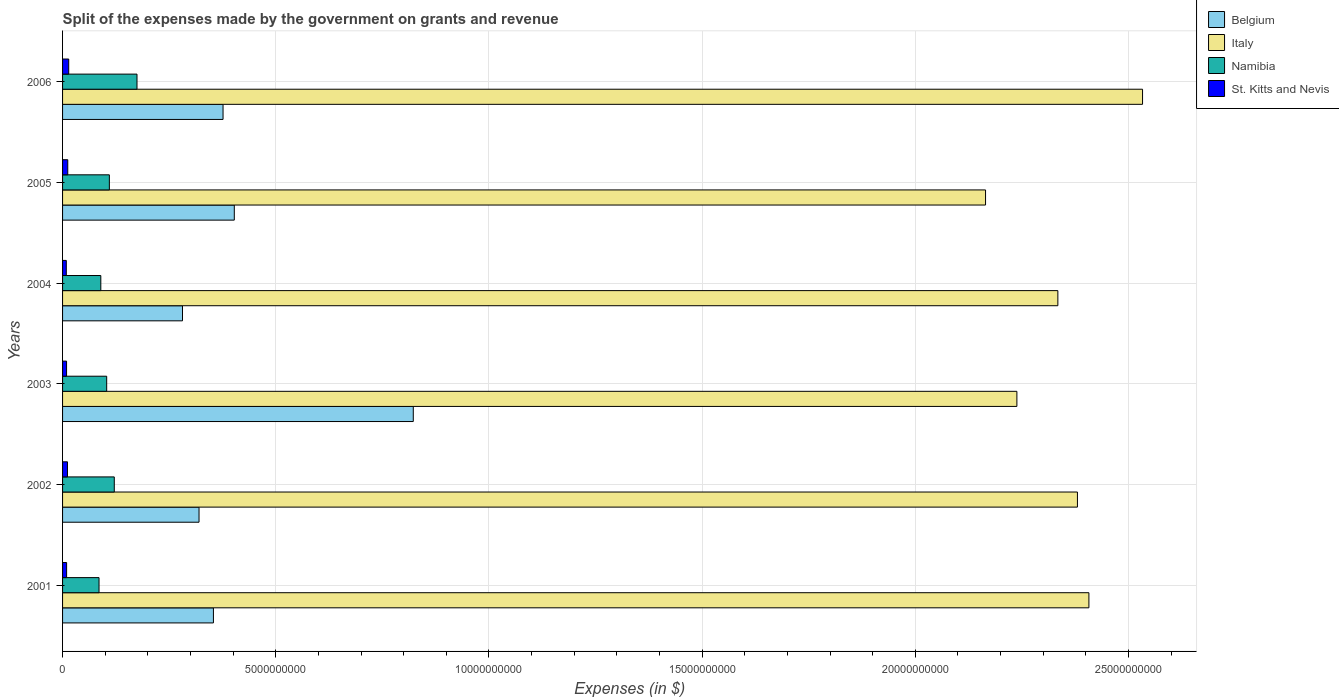How many groups of bars are there?
Provide a succinct answer. 6. In how many cases, is the number of bars for a given year not equal to the number of legend labels?
Your answer should be very brief. 0. What is the expenses made by the government on grants and revenue in St. Kitts and Nevis in 2001?
Provide a succinct answer. 9.49e+07. Across all years, what is the maximum expenses made by the government on grants and revenue in Belgium?
Your answer should be compact. 8.23e+09. Across all years, what is the minimum expenses made by the government on grants and revenue in Namibia?
Ensure brevity in your answer.  8.55e+08. In which year was the expenses made by the government on grants and revenue in Italy minimum?
Provide a short and direct response. 2005. What is the total expenses made by the government on grants and revenue in Italy in the graph?
Give a very brief answer. 1.41e+11. What is the difference between the expenses made by the government on grants and revenue in Belgium in 2003 and that in 2004?
Keep it short and to the point. 5.41e+09. What is the difference between the expenses made by the government on grants and revenue in St. Kitts and Nevis in 2004 and the expenses made by the government on grants and revenue in Belgium in 2002?
Provide a succinct answer. -3.11e+09. What is the average expenses made by the government on grants and revenue in Italy per year?
Your answer should be very brief. 2.34e+1. In the year 2003, what is the difference between the expenses made by the government on grants and revenue in Belgium and expenses made by the government on grants and revenue in Namibia?
Offer a terse response. 7.19e+09. In how many years, is the expenses made by the government on grants and revenue in St. Kitts and Nevis greater than 13000000000 $?
Your answer should be compact. 0. What is the ratio of the expenses made by the government on grants and revenue in Belgium in 2002 to that in 2003?
Provide a succinct answer. 0.39. Is the difference between the expenses made by the government on grants and revenue in Belgium in 2004 and 2006 greater than the difference between the expenses made by the government on grants and revenue in Namibia in 2004 and 2006?
Your answer should be compact. No. What is the difference between the highest and the second highest expenses made by the government on grants and revenue in Italy?
Provide a succinct answer. 1.26e+09. What is the difference between the highest and the lowest expenses made by the government on grants and revenue in St. Kitts and Nevis?
Provide a succinct answer. 5.68e+07. In how many years, is the expenses made by the government on grants and revenue in Italy greater than the average expenses made by the government on grants and revenue in Italy taken over all years?
Keep it short and to the point. 3. Is the sum of the expenses made by the government on grants and revenue in Namibia in 2001 and 2003 greater than the maximum expenses made by the government on grants and revenue in Belgium across all years?
Your answer should be compact. No. Is it the case that in every year, the sum of the expenses made by the government on grants and revenue in St. Kitts and Nevis and expenses made by the government on grants and revenue in Belgium is greater than the sum of expenses made by the government on grants and revenue in Namibia and expenses made by the government on grants and revenue in Italy?
Make the answer very short. Yes. What does the 2nd bar from the top in 2001 represents?
Offer a terse response. Namibia. What does the 4th bar from the bottom in 2006 represents?
Provide a short and direct response. St. Kitts and Nevis. How many years are there in the graph?
Provide a succinct answer. 6. What is the difference between two consecutive major ticks on the X-axis?
Give a very brief answer. 5.00e+09. Does the graph contain any zero values?
Keep it short and to the point. No. How many legend labels are there?
Keep it short and to the point. 4. How are the legend labels stacked?
Ensure brevity in your answer.  Vertical. What is the title of the graph?
Ensure brevity in your answer.  Split of the expenses made by the government on grants and revenue. What is the label or title of the X-axis?
Offer a terse response. Expenses (in $). What is the Expenses (in $) in Belgium in 2001?
Your answer should be compact. 3.54e+09. What is the Expenses (in $) in Italy in 2001?
Your response must be concise. 2.41e+1. What is the Expenses (in $) in Namibia in 2001?
Provide a succinct answer. 8.55e+08. What is the Expenses (in $) in St. Kitts and Nevis in 2001?
Provide a succinct answer. 9.49e+07. What is the Expenses (in $) in Belgium in 2002?
Keep it short and to the point. 3.20e+09. What is the Expenses (in $) of Italy in 2002?
Your answer should be very brief. 2.38e+1. What is the Expenses (in $) in Namibia in 2002?
Your answer should be very brief. 1.21e+09. What is the Expenses (in $) in St. Kitts and Nevis in 2002?
Your response must be concise. 1.15e+08. What is the Expenses (in $) in Belgium in 2003?
Ensure brevity in your answer.  8.23e+09. What is the Expenses (in $) of Italy in 2003?
Keep it short and to the point. 2.24e+1. What is the Expenses (in $) in Namibia in 2003?
Ensure brevity in your answer.  1.03e+09. What is the Expenses (in $) in St. Kitts and Nevis in 2003?
Make the answer very short. 9.36e+07. What is the Expenses (in $) in Belgium in 2004?
Give a very brief answer. 2.81e+09. What is the Expenses (in $) in Italy in 2004?
Ensure brevity in your answer.  2.33e+1. What is the Expenses (in $) of Namibia in 2004?
Offer a terse response. 8.97e+08. What is the Expenses (in $) in St. Kitts and Nevis in 2004?
Ensure brevity in your answer.  8.76e+07. What is the Expenses (in $) in Belgium in 2005?
Your answer should be compact. 4.03e+09. What is the Expenses (in $) of Italy in 2005?
Your answer should be very brief. 2.16e+1. What is the Expenses (in $) of Namibia in 2005?
Make the answer very short. 1.10e+09. What is the Expenses (in $) in St. Kitts and Nevis in 2005?
Offer a very short reply. 1.22e+08. What is the Expenses (in $) of Belgium in 2006?
Your answer should be very brief. 3.76e+09. What is the Expenses (in $) of Italy in 2006?
Make the answer very short. 2.53e+1. What is the Expenses (in $) in Namibia in 2006?
Provide a succinct answer. 1.75e+09. What is the Expenses (in $) in St. Kitts and Nevis in 2006?
Your answer should be compact. 1.44e+08. Across all years, what is the maximum Expenses (in $) in Belgium?
Provide a short and direct response. 8.23e+09. Across all years, what is the maximum Expenses (in $) of Italy?
Make the answer very short. 2.53e+1. Across all years, what is the maximum Expenses (in $) of Namibia?
Your answer should be very brief. 1.75e+09. Across all years, what is the maximum Expenses (in $) in St. Kitts and Nevis?
Offer a terse response. 1.44e+08. Across all years, what is the minimum Expenses (in $) of Belgium?
Your answer should be compact. 2.81e+09. Across all years, what is the minimum Expenses (in $) of Italy?
Give a very brief answer. 2.16e+1. Across all years, what is the minimum Expenses (in $) in Namibia?
Your answer should be compact. 8.55e+08. Across all years, what is the minimum Expenses (in $) of St. Kitts and Nevis?
Offer a very short reply. 8.76e+07. What is the total Expenses (in $) of Belgium in the graph?
Ensure brevity in your answer.  2.56e+1. What is the total Expenses (in $) in Italy in the graph?
Provide a succinct answer. 1.41e+11. What is the total Expenses (in $) in Namibia in the graph?
Your answer should be very brief. 6.84e+09. What is the total Expenses (in $) in St. Kitts and Nevis in the graph?
Offer a terse response. 6.58e+08. What is the difference between the Expenses (in $) in Belgium in 2001 and that in 2002?
Your response must be concise. 3.37e+08. What is the difference between the Expenses (in $) in Italy in 2001 and that in 2002?
Provide a short and direct response. 2.69e+08. What is the difference between the Expenses (in $) in Namibia in 2001 and that in 2002?
Your answer should be compact. -3.58e+08. What is the difference between the Expenses (in $) in St. Kitts and Nevis in 2001 and that in 2002?
Provide a short and direct response. -2.04e+07. What is the difference between the Expenses (in $) of Belgium in 2001 and that in 2003?
Provide a short and direct response. -4.69e+09. What is the difference between the Expenses (in $) of Italy in 2001 and that in 2003?
Your response must be concise. 1.69e+09. What is the difference between the Expenses (in $) of Namibia in 2001 and that in 2003?
Give a very brief answer. -1.80e+08. What is the difference between the Expenses (in $) of St. Kitts and Nevis in 2001 and that in 2003?
Provide a short and direct response. 1.30e+06. What is the difference between the Expenses (in $) of Belgium in 2001 and that in 2004?
Provide a succinct answer. 7.25e+08. What is the difference between the Expenses (in $) in Italy in 2001 and that in 2004?
Your answer should be compact. 7.28e+08. What is the difference between the Expenses (in $) in Namibia in 2001 and that in 2004?
Your answer should be compact. -4.18e+07. What is the difference between the Expenses (in $) in St. Kitts and Nevis in 2001 and that in 2004?
Ensure brevity in your answer.  7.30e+06. What is the difference between the Expenses (in $) of Belgium in 2001 and that in 2005?
Make the answer very short. -4.90e+08. What is the difference between the Expenses (in $) in Italy in 2001 and that in 2005?
Keep it short and to the point. 2.42e+09. What is the difference between the Expenses (in $) of Namibia in 2001 and that in 2005?
Your answer should be very brief. -2.42e+08. What is the difference between the Expenses (in $) of St. Kitts and Nevis in 2001 and that in 2005?
Offer a very short reply. -2.69e+07. What is the difference between the Expenses (in $) of Belgium in 2001 and that in 2006?
Keep it short and to the point. -2.26e+08. What is the difference between the Expenses (in $) of Italy in 2001 and that in 2006?
Your response must be concise. -1.26e+09. What is the difference between the Expenses (in $) in Namibia in 2001 and that in 2006?
Ensure brevity in your answer.  -8.90e+08. What is the difference between the Expenses (in $) of St. Kitts and Nevis in 2001 and that in 2006?
Provide a short and direct response. -4.95e+07. What is the difference between the Expenses (in $) of Belgium in 2002 and that in 2003?
Keep it short and to the point. -5.02e+09. What is the difference between the Expenses (in $) of Italy in 2002 and that in 2003?
Offer a terse response. 1.42e+09. What is the difference between the Expenses (in $) in Namibia in 2002 and that in 2003?
Make the answer very short. 1.78e+08. What is the difference between the Expenses (in $) in St. Kitts and Nevis in 2002 and that in 2003?
Offer a terse response. 2.17e+07. What is the difference between the Expenses (in $) in Belgium in 2002 and that in 2004?
Ensure brevity in your answer.  3.88e+08. What is the difference between the Expenses (in $) in Italy in 2002 and that in 2004?
Your answer should be very brief. 4.59e+08. What is the difference between the Expenses (in $) in Namibia in 2002 and that in 2004?
Your answer should be very brief. 3.16e+08. What is the difference between the Expenses (in $) in St. Kitts and Nevis in 2002 and that in 2004?
Your answer should be compact. 2.77e+07. What is the difference between the Expenses (in $) in Belgium in 2002 and that in 2005?
Ensure brevity in your answer.  -8.27e+08. What is the difference between the Expenses (in $) of Italy in 2002 and that in 2005?
Your response must be concise. 2.16e+09. What is the difference between the Expenses (in $) in Namibia in 2002 and that in 2005?
Provide a short and direct response. 1.15e+08. What is the difference between the Expenses (in $) of St. Kitts and Nevis in 2002 and that in 2005?
Provide a succinct answer. -6.50e+06. What is the difference between the Expenses (in $) in Belgium in 2002 and that in 2006?
Your answer should be compact. -5.63e+08. What is the difference between the Expenses (in $) of Italy in 2002 and that in 2006?
Ensure brevity in your answer.  -1.53e+09. What is the difference between the Expenses (in $) of Namibia in 2002 and that in 2006?
Keep it short and to the point. -5.33e+08. What is the difference between the Expenses (in $) of St. Kitts and Nevis in 2002 and that in 2006?
Provide a short and direct response. -2.91e+07. What is the difference between the Expenses (in $) of Belgium in 2003 and that in 2004?
Ensure brevity in your answer.  5.41e+09. What is the difference between the Expenses (in $) of Italy in 2003 and that in 2004?
Offer a very short reply. -9.61e+08. What is the difference between the Expenses (in $) in Namibia in 2003 and that in 2004?
Offer a very short reply. 1.38e+08. What is the difference between the Expenses (in $) of Belgium in 2003 and that in 2005?
Your response must be concise. 4.20e+09. What is the difference between the Expenses (in $) in Italy in 2003 and that in 2005?
Offer a very short reply. 7.35e+08. What is the difference between the Expenses (in $) of Namibia in 2003 and that in 2005?
Provide a succinct answer. -6.28e+07. What is the difference between the Expenses (in $) of St. Kitts and Nevis in 2003 and that in 2005?
Your answer should be very brief. -2.82e+07. What is the difference between the Expenses (in $) of Belgium in 2003 and that in 2006?
Your response must be concise. 4.46e+09. What is the difference between the Expenses (in $) in Italy in 2003 and that in 2006?
Your answer should be very brief. -2.95e+09. What is the difference between the Expenses (in $) in Namibia in 2003 and that in 2006?
Provide a succinct answer. -7.11e+08. What is the difference between the Expenses (in $) in St. Kitts and Nevis in 2003 and that in 2006?
Keep it short and to the point. -5.08e+07. What is the difference between the Expenses (in $) in Belgium in 2004 and that in 2005?
Your answer should be compact. -1.21e+09. What is the difference between the Expenses (in $) in Italy in 2004 and that in 2005?
Provide a succinct answer. 1.70e+09. What is the difference between the Expenses (in $) in Namibia in 2004 and that in 2005?
Provide a short and direct response. -2.00e+08. What is the difference between the Expenses (in $) of St. Kitts and Nevis in 2004 and that in 2005?
Offer a terse response. -3.42e+07. What is the difference between the Expenses (in $) of Belgium in 2004 and that in 2006?
Offer a very short reply. -9.51e+08. What is the difference between the Expenses (in $) of Italy in 2004 and that in 2006?
Give a very brief answer. -1.99e+09. What is the difference between the Expenses (in $) of Namibia in 2004 and that in 2006?
Provide a short and direct response. -8.49e+08. What is the difference between the Expenses (in $) of St. Kitts and Nevis in 2004 and that in 2006?
Your answer should be compact. -5.68e+07. What is the difference between the Expenses (in $) in Belgium in 2005 and that in 2006?
Make the answer very short. 2.64e+08. What is the difference between the Expenses (in $) of Italy in 2005 and that in 2006?
Ensure brevity in your answer.  -3.68e+09. What is the difference between the Expenses (in $) in Namibia in 2005 and that in 2006?
Make the answer very short. -6.48e+08. What is the difference between the Expenses (in $) in St. Kitts and Nevis in 2005 and that in 2006?
Your answer should be compact. -2.26e+07. What is the difference between the Expenses (in $) of Belgium in 2001 and the Expenses (in $) of Italy in 2002?
Ensure brevity in your answer.  -2.03e+1. What is the difference between the Expenses (in $) in Belgium in 2001 and the Expenses (in $) in Namibia in 2002?
Give a very brief answer. 2.32e+09. What is the difference between the Expenses (in $) in Belgium in 2001 and the Expenses (in $) in St. Kitts and Nevis in 2002?
Keep it short and to the point. 3.42e+09. What is the difference between the Expenses (in $) in Italy in 2001 and the Expenses (in $) in Namibia in 2002?
Offer a very short reply. 2.29e+1. What is the difference between the Expenses (in $) of Italy in 2001 and the Expenses (in $) of St. Kitts and Nevis in 2002?
Offer a terse response. 2.40e+1. What is the difference between the Expenses (in $) in Namibia in 2001 and the Expenses (in $) in St. Kitts and Nevis in 2002?
Provide a succinct answer. 7.40e+08. What is the difference between the Expenses (in $) of Belgium in 2001 and the Expenses (in $) of Italy in 2003?
Give a very brief answer. -1.88e+1. What is the difference between the Expenses (in $) in Belgium in 2001 and the Expenses (in $) in Namibia in 2003?
Give a very brief answer. 2.50e+09. What is the difference between the Expenses (in $) of Belgium in 2001 and the Expenses (in $) of St. Kitts and Nevis in 2003?
Ensure brevity in your answer.  3.44e+09. What is the difference between the Expenses (in $) of Italy in 2001 and the Expenses (in $) of Namibia in 2003?
Provide a short and direct response. 2.30e+1. What is the difference between the Expenses (in $) of Italy in 2001 and the Expenses (in $) of St. Kitts and Nevis in 2003?
Provide a succinct answer. 2.40e+1. What is the difference between the Expenses (in $) in Namibia in 2001 and the Expenses (in $) in St. Kitts and Nevis in 2003?
Give a very brief answer. 7.62e+08. What is the difference between the Expenses (in $) of Belgium in 2001 and the Expenses (in $) of Italy in 2004?
Ensure brevity in your answer.  -1.98e+1. What is the difference between the Expenses (in $) of Belgium in 2001 and the Expenses (in $) of Namibia in 2004?
Your answer should be compact. 2.64e+09. What is the difference between the Expenses (in $) of Belgium in 2001 and the Expenses (in $) of St. Kitts and Nevis in 2004?
Offer a very short reply. 3.45e+09. What is the difference between the Expenses (in $) of Italy in 2001 and the Expenses (in $) of Namibia in 2004?
Give a very brief answer. 2.32e+1. What is the difference between the Expenses (in $) of Italy in 2001 and the Expenses (in $) of St. Kitts and Nevis in 2004?
Your answer should be very brief. 2.40e+1. What is the difference between the Expenses (in $) in Namibia in 2001 and the Expenses (in $) in St. Kitts and Nevis in 2004?
Offer a terse response. 7.68e+08. What is the difference between the Expenses (in $) of Belgium in 2001 and the Expenses (in $) of Italy in 2005?
Your response must be concise. -1.81e+1. What is the difference between the Expenses (in $) of Belgium in 2001 and the Expenses (in $) of Namibia in 2005?
Provide a short and direct response. 2.44e+09. What is the difference between the Expenses (in $) in Belgium in 2001 and the Expenses (in $) in St. Kitts and Nevis in 2005?
Your answer should be compact. 3.42e+09. What is the difference between the Expenses (in $) in Italy in 2001 and the Expenses (in $) in Namibia in 2005?
Give a very brief answer. 2.30e+1. What is the difference between the Expenses (in $) in Italy in 2001 and the Expenses (in $) in St. Kitts and Nevis in 2005?
Give a very brief answer. 2.39e+1. What is the difference between the Expenses (in $) in Namibia in 2001 and the Expenses (in $) in St. Kitts and Nevis in 2005?
Your response must be concise. 7.34e+08. What is the difference between the Expenses (in $) of Belgium in 2001 and the Expenses (in $) of Italy in 2006?
Make the answer very short. -2.18e+1. What is the difference between the Expenses (in $) in Belgium in 2001 and the Expenses (in $) in Namibia in 2006?
Provide a succinct answer. 1.79e+09. What is the difference between the Expenses (in $) of Belgium in 2001 and the Expenses (in $) of St. Kitts and Nevis in 2006?
Your response must be concise. 3.39e+09. What is the difference between the Expenses (in $) of Italy in 2001 and the Expenses (in $) of Namibia in 2006?
Offer a very short reply. 2.23e+1. What is the difference between the Expenses (in $) of Italy in 2001 and the Expenses (in $) of St. Kitts and Nevis in 2006?
Give a very brief answer. 2.39e+1. What is the difference between the Expenses (in $) of Namibia in 2001 and the Expenses (in $) of St. Kitts and Nevis in 2006?
Give a very brief answer. 7.11e+08. What is the difference between the Expenses (in $) of Belgium in 2002 and the Expenses (in $) of Italy in 2003?
Your answer should be very brief. -1.92e+1. What is the difference between the Expenses (in $) of Belgium in 2002 and the Expenses (in $) of Namibia in 2003?
Offer a very short reply. 2.17e+09. What is the difference between the Expenses (in $) of Belgium in 2002 and the Expenses (in $) of St. Kitts and Nevis in 2003?
Your response must be concise. 3.11e+09. What is the difference between the Expenses (in $) of Italy in 2002 and the Expenses (in $) of Namibia in 2003?
Provide a short and direct response. 2.28e+1. What is the difference between the Expenses (in $) of Italy in 2002 and the Expenses (in $) of St. Kitts and Nevis in 2003?
Offer a terse response. 2.37e+1. What is the difference between the Expenses (in $) of Namibia in 2002 and the Expenses (in $) of St. Kitts and Nevis in 2003?
Provide a succinct answer. 1.12e+09. What is the difference between the Expenses (in $) in Belgium in 2002 and the Expenses (in $) in Italy in 2004?
Your answer should be compact. -2.01e+1. What is the difference between the Expenses (in $) of Belgium in 2002 and the Expenses (in $) of Namibia in 2004?
Your answer should be very brief. 2.30e+09. What is the difference between the Expenses (in $) of Belgium in 2002 and the Expenses (in $) of St. Kitts and Nevis in 2004?
Provide a succinct answer. 3.11e+09. What is the difference between the Expenses (in $) in Italy in 2002 and the Expenses (in $) in Namibia in 2004?
Offer a terse response. 2.29e+1. What is the difference between the Expenses (in $) in Italy in 2002 and the Expenses (in $) in St. Kitts and Nevis in 2004?
Your answer should be very brief. 2.37e+1. What is the difference between the Expenses (in $) of Namibia in 2002 and the Expenses (in $) of St. Kitts and Nevis in 2004?
Offer a very short reply. 1.13e+09. What is the difference between the Expenses (in $) in Belgium in 2002 and the Expenses (in $) in Italy in 2005?
Provide a short and direct response. -1.84e+1. What is the difference between the Expenses (in $) in Belgium in 2002 and the Expenses (in $) in Namibia in 2005?
Offer a terse response. 2.10e+09. What is the difference between the Expenses (in $) in Belgium in 2002 and the Expenses (in $) in St. Kitts and Nevis in 2005?
Offer a very short reply. 3.08e+09. What is the difference between the Expenses (in $) of Italy in 2002 and the Expenses (in $) of Namibia in 2005?
Make the answer very short. 2.27e+1. What is the difference between the Expenses (in $) in Italy in 2002 and the Expenses (in $) in St. Kitts and Nevis in 2005?
Give a very brief answer. 2.37e+1. What is the difference between the Expenses (in $) of Namibia in 2002 and the Expenses (in $) of St. Kitts and Nevis in 2005?
Give a very brief answer. 1.09e+09. What is the difference between the Expenses (in $) in Belgium in 2002 and the Expenses (in $) in Italy in 2006?
Give a very brief answer. -2.21e+1. What is the difference between the Expenses (in $) of Belgium in 2002 and the Expenses (in $) of Namibia in 2006?
Keep it short and to the point. 1.45e+09. What is the difference between the Expenses (in $) of Belgium in 2002 and the Expenses (in $) of St. Kitts and Nevis in 2006?
Offer a very short reply. 3.06e+09. What is the difference between the Expenses (in $) of Italy in 2002 and the Expenses (in $) of Namibia in 2006?
Provide a succinct answer. 2.21e+1. What is the difference between the Expenses (in $) in Italy in 2002 and the Expenses (in $) in St. Kitts and Nevis in 2006?
Give a very brief answer. 2.37e+1. What is the difference between the Expenses (in $) of Namibia in 2002 and the Expenses (in $) of St. Kitts and Nevis in 2006?
Offer a very short reply. 1.07e+09. What is the difference between the Expenses (in $) in Belgium in 2003 and the Expenses (in $) in Italy in 2004?
Provide a succinct answer. -1.51e+1. What is the difference between the Expenses (in $) in Belgium in 2003 and the Expenses (in $) in Namibia in 2004?
Your response must be concise. 7.33e+09. What is the difference between the Expenses (in $) in Belgium in 2003 and the Expenses (in $) in St. Kitts and Nevis in 2004?
Your response must be concise. 8.14e+09. What is the difference between the Expenses (in $) in Italy in 2003 and the Expenses (in $) in Namibia in 2004?
Give a very brief answer. 2.15e+1. What is the difference between the Expenses (in $) of Italy in 2003 and the Expenses (in $) of St. Kitts and Nevis in 2004?
Your answer should be very brief. 2.23e+1. What is the difference between the Expenses (in $) of Namibia in 2003 and the Expenses (in $) of St. Kitts and Nevis in 2004?
Provide a short and direct response. 9.47e+08. What is the difference between the Expenses (in $) in Belgium in 2003 and the Expenses (in $) in Italy in 2005?
Your response must be concise. -1.34e+1. What is the difference between the Expenses (in $) in Belgium in 2003 and the Expenses (in $) in Namibia in 2005?
Your response must be concise. 7.13e+09. What is the difference between the Expenses (in $) in Belgium in 2003 and the Expenses (in $) in St. Kitts and Nevis in 2005?
Give a very brief answer. 8.10e+09. What is the difference between the Expenses (in $) of Italy in 2003 and the Expenses (in $) of Namibia in 2005?
Keep it short and to the point. 2.13e+1. What is the difference between the Expenses (in $) in Italy in 2003 and the Expenses (in $) in St. Kitts and Nevis in 2005?
Your response must be concise. 2.23e+1. What is the difference between the Expenses (in $) in Namibia in 2003 and the Expenses (in $) in St. Kitts and Nevis in 2005?
Ensure brevity in your answer.  9.13e+08. What is the difference between the Expenses (in $) of Belgium in 2003 and the Expenses (in $) of Italy in 2006?
Provide a short and direct response. -1.71e+1. What is the difference between the Expenses (in $) in Belgium in 2003 and the Expenses (in $) in Namibia in 2006?
Make the answer very short. 6.48e+09. What is the difference between the Expenses (in $) in Belgium in 2003 and the Expenses (in $) in St. Kitts and Nevis in 2006?
Give a very brief answer. 8.08e+09. What is the difference between the Expenses (in $) in Italy in 2003 and the Expenses (in $) in Namibia in 2006?
Your answer should be very brief. 2.06e+1. What is the difference between the Expenses (in $) of Italy in 2003 and the Expenses (in $) of St. Kitts and Nevis in 2006?
Make the answer very short. 2.22e+1. What is the difference between the Expenses (in $) of Namibia in 2003 and the Expenses (in $) of St. Kitts and Nevis in 2006?
Give a very brief answer. 8.90e+08. What is the difference between the Expenses (in $) in Belgium in 2004 and the Expenses (in $) in Italy in 2005?
Your response must be concise. -1.88e+1. What is the difference between the Expenses (in $) in Belgium in 2004 and the Expenses (in $) in Namibia in 2005?
Offer a very short reply. 1.72e+09. What is the difference between the Expenses (in $) of Belgium in 2004 and the Expenses (in $) of St. Kitts and Nevis in 2005?
Keep it short and to the point. 2.69e+09. What is the difference between the Expenses (in $) of Italy in 2004 and the Expenses (in $) of Namibia in 2005?
Give a very brief answer. 2.22e+1. What is the difference between the Expenses (in $) in Italy in 2004 and the Expenses (in $) in St. Kitts and Nevis in 2005?
Offer a terse response. 2.32e+1. What is the difference between the Expenses (in $) in Namibia in 2004 and the Expenses (in $) in St. Kitts and Nevis in 2005?
Provide a succinct answer. 7.75e+08. What is the difference between the Expenses (in $) in Belgium in 2004 and the Expenses (in $) in Italy in 2006?
Keep it short and to the point. -2.25e+1. What is the difference between the Expenses (in $) of Belgium in 2004 and the Expenses (in $) of Namibia in 2006?
Provide a succinct answer. 1.07e+09. What is the difference between the Expenses (in $) of Belgium in 2004 and the Expenses (in $) of St. Kitts and Nevis in 2006?
Offer a terse response. 2.67e+09. What is the difference between the Expenses (in $) in Italy in 2004 and the Expenses (in $) in Namibia in 2006?
Provide a succinct answer. 2.16e+1. What is the difference between the Expenses (in $) of Italy in 2004 and the Expenses (in $) of St. Kitts and Nevis in 2006?
Keep it short and to the point. 2.32e+1. What is the difference between the Expenses (in $) in Namibia in 2004 and the Expenses (in $) in St. Kitts and Nevis in 2006?
Your answer should be compact. 7.53e+08. What is the difference between the Expenses (in $) of Belgium in 2005 and the Expenses (in $) of Italy in 2006?
Provide a short and direct response. -2.13e+1. What is the difference between the Expenses (in $) in Belgium in 2005 and the Expenses (in $) in Namibia in 2006?
Offer a terse response. 2.28e+09. What is the difference between the Expenses (in $) in Belgium in 2005 and the Expenses (in $) in St. Kitts and Nevis in 2006?
Your answer should be very brief. 3.88e+09. What is the difference between the Expenses (in $) of Italy in 2005 and the Expenses (in $) of Namibia in 2006?
Ensure brevity in your answer.  1.99e+1. What is the difference between the Expenses (in $) of Italy in 2005 and the Expenses (in $) of St. Kitts and Nevis in 2006?
Make the answer very short. 2.15e+1. What is the difference between the Expenses (in $) of Namibia in 2005 and the Expenses (in $) of St. Kitts and Nevis in 2006?
Give a very brief answer. 9.53e+08. What is the average Expenses (in $) of Belgium per year?
Your answer should be compact. 4.26e+09. What is the average Expenses (in $) of Italy per year?
Keep it short and to the point. 2.34e+1. What is the average Expenses (in $) in Namibia per year?
Your response must be concise. 1.14e+09. What is the average Expenses (in $) in St. Kitts and Nevis per year?
Your answer should be very brief. 1.10e+08. In the year 2001, what is the difference between the Expenses (in $) of Belgium and Expenses (in $) of Italy?
Offer a terse response. -2.05e+1. In the year 2001, what is the difference between the Expenses (in $) in Belgium and Expenses (in $) in Namibia?
Offer a very short reply. 2.68e+09. In the year 2001, what is the difference between the Expenses (in $) of Belgium and Expenses (in $) of St. Kitts and Nevis?
Ensure brevity in your answer.  3.44e+09. In the year 2001, what is the difference between the Expenses (in $) in Italy and Expenses (in $) in Namibia?
Provide a succinct answer. 2.32e+1. In the year 2001, what is the difference between the Expenses (in $) in Italy and Expenses (in $) in St. Kitts and Nevis?
Your answer should be compact. 2.40e+1. In the year 2001, what is the difference between the Expenses (in $) of Namibia and Expenses (in $) of St. Kitts and Nevis?
Provide a short and direct response. 7.60e+08. In the year 2002, what is the difference between the Expenses (in $) in Belgium and Expenses (in $) in Italy?
Your response must be concise. -2.06e+1. In the year 2002, what is the difference between the Expenses (in $) of Belgium and Expenses (in $) of Namibia?
Your answer should be very brief. 1.99e+09. In the year 2002, what is the difference between the Expenses (in $) in Belgium and Expenses (in $) in St. Kitts and Nevis?
Keep it short and to the point. 3.09e+09. In the year 2002, what is the difference between the Expenses (in $) in Italy and Expenses (in $) in Namibia?
Keep it short and to the point. 2.26e+1. In the year 2002, what is the difference between the Expenses (in $) in Italy and Expenses (in $) in St. Kitts and Nevis?
Your response must be concise. 2.37e+1. In the year 2002, what is the difference between the Expenses (in $) in Namibia and Expenses (in $) in St. Kitts and Nevis?
Ensure brevity in your answer.  1.10e+09. In the year 2003, what is the difference between the Expenses (in $) in Belgium and Expenses (in $) in Italy?
Keep it short and to the point. -1.42e+1. In the year 2003, what is the difference between the Expenses (in $) of Belgium and Expenses (in $) of Namibia?
Make the answer very short. 7.19e+09. In the year 2003, what is the difference between the Expenses (in $) in Belgium and Expenses (in $) in St. Kitts and Nevis?
Your answer should be compact. 8.13e+09. In the year 2003, what is the difference between the Expenses (in $) in Italy and Expenses (in $) in Namibia?
Offer a terse response. 2.13e+1. In the year 2003, what is the difference between the Expenses (in $) in Italy and Expenses (in $) in St. Kitts and Nevis?
Provide a succinct answer. 2.23e+1. In the year 2003, what is the difference between the Expenses (in $) in Namibia and Expenses (in $) in St. Kitts and Nevis?
Keep it short and to the point. 9.41e+08. In the year 2004, what is the difference between the Expenses (in $) of Belgium and Expenses (in $) of Italy?
Your answer should be very brief. -2.05e+1. In the year 2004, what is the difference between the Expenses (in $) in Belgium and Expenses (in $) in Namibia?
Your answer should be compact. 1.92e+09. In the year 2004, what is the difference between the Expenses (in $) in Belgium and Expenses (in $) in St. Kitts and Nevis?
Make the answer very short. 2.73e+09. In the year 2004, what is the difference between the Expenses (in $) in Italy and Expenses (in $) in Namibia?
Provide a short and direct response. 2.24e+1. In the year 2004, what is the difference between the Expenses (in $) in Italy and Expenses (in $) in St. Kitts and Nevis?
Your response must be concise. 2.33e+1. In the year 2004, what is the difference between the Expenses (in $) in Namibia and Expenses (in $) in St. Kitts and Nevis?
Keep it short and to the point. 8.10e+08. In the year 2005, what is the difference between the Expenses (in $) in Belgium and Expenses (in $) in Italy?
Keep it short and to the point. -1.76e+1. In the year 2005, what is the difference between the Expenses (in $) in Belgium and Expenses (in $) in Namibia?
Give a very brief answer. 2.93e+09. In the year 2005, what is the difference between the Expenses (in $) in Belgium and Expenses (in $) in St. Kitts and Nevis?
Your answer should be very brief. 3.91e+09. In the year 2005, what is the difference between the Expenses (in $) of Italy and Expenses (in $) of Namibia?
Provide a short and direct response. 2.05e+1. In the year 2005, what is the difference between the Expenses (in $) of Italy and Expenses (in $) of St. Kitts and Nevis?
Ensure brevity in your answer.  2.15e+1. In the year 2005, what is the difference between the Expenses (in $) in Namibia and Expenses (in $) in St. Kitts and Nevis?
Your answer should be very brief. 9.76e+08. In the year 2006, what is the difference between the Expenses (in $) of Belgium and Expenses (in $) of Italy?
Offer a very short reply. -2.16e+1. In the year 2006, what is the difference between the Expenses (in $) in Belgium and Expenses (in $) in Namibia?
Provide a short and direct response. 2.02e+09. In the year 2006, what is the difference between the Expenses (in $) of Belgium and Expenses (in $) of St. Kitts and Nevis?
Your answer should be very brief. 3.62e+09. In the year 2006, what is the difference between the Expenses (in $) of Italy and Expenses (in $) of Namibia?
Make the answer very short. 2.36e+1. In the year 2006, what is the difference between the Expenses (in $) of Italy and Expenses (in $) of St. Kitts and Nevis?
Make the answer very short. 2.52e+1. In the year 2006, what is the difference between the Expenses (in $) of Namibia and Expenses (in $) of St. Kitts and Nevis?
Keep it short and to the point. 1.60e+09. What is the ratio of the Expenses (in $) in Belgium in 2001 to that in 2002?
Offer a terse response. 1.11. What is the ratio of the Expenses (in $) of Italy in 2001 to that in 2002?
Your answer should be compact. 1.01. What is the ratio of the Expenses (in $) in Namibia in 2001 to that in 2002?
Provide a succinct answer. 0.71. What is the ratio of the Expenses (in $) in St. Kitts and Nevis in 2001 to that in 2002?
Your answer should be very brief. 0.82. What is the ratio of the Expenses (in $) in Belgium in 2001 to that in 2003?
Offer a very short reply. 0.43. What is the ratio of the Expenses (in $) in Italy in 2001 to that in 2003?
Your answer should be compact. 1.08. What is the ratio of the Expenses (in $) in Namibia in 2001 to that in 2003?
Your answer should be very brief. 0.83. What is the ratio of the Expenses (in $) in St. Kitts and Nevis in 2001 to that in 2003?
Make the answer very short. 1.01. What is the ratio of the Expenses (in $) in Belgium in 2001 to that in 2004?
Offer a very short reply. 1.26. What is the ratio of the Expenses (in $) of Italy in 2001 to that in 2004?
Keep it short and to the point. 1.03. What is the ratio of the Expenses (in $) in Namibia in 2001 to that in 2004?
Give a very brief answer. 0.95. What is the ratio of the Expenses (in $) of Belgium in 2001 to that in 2005?
Provide a short and direct response. 0.88. What is the ratio of the Expenses (in $) in Italy in 2001 to that in 2005?
Give a very brief answer. 1.11. What is the ratio of the Expenses (in $) of Namibia in 2001 to that in 2005?
Ensure brevity in your answer.  0.78. What is the ratio of the Expenses (in $) of St. Kitts and Nevis in 2001 to that in 2005?
Give a very brief answer. 0.78. What is the ratio of the Expenses (in $) of Belgium in 2001 to that in 2006?
Offer a very short reply. 0.94. What is the ratio of the Expenses (in $) in Italy in 2001 to that in 2006?
Your response must be concise. 0.95. What is the ratio of the Expenses (in $) of Namibia in 2001 to that in 2006?
Provide a succinct answer. 0.49. What is the ratio of the Expenses (in $) of St. Kitts and Nevis in 2001 to that in 2006?
Provide a succinct answer. 0.66. What is the ratio of the Expenses (in $) in Belgium in 2002 to that in 2003?
Your answer should be very brief. 0.39. What is the ratio of the Expenses (in $) of Italy in 2002 to that in 2003?
Offer a terse response. 1.06. What is the ratio of the Expenses (in $) in Namibia in 2002 to that in 2003?
Make the answer very short. 1.17. What is the ratio of the Expenses (in $) in St. Kitts and Nevis in 2002 to that in 2003?
Keep it short and to the point. 1.23. What is the ratio of the Expenses (in $) of Belgium in 2002 to that in 2004?
Offer a very short reply. 1.14. What is the ratio of the Expenses (in $) of Italy in 2002 to that in 2004?
Provide a short and direct response. 1.02. What is the ratio of the Expenses (in $) in Namibia in 2002 to that in 2004?
Keep it short and to the point. 1.35. What is the ratio of the Expenses (in $) in St. Kitts and Nevis in 2002 to that in 2004?
Offer a terse response. 1.32. What is the ratio of the Expenses (in $) in Belgium in 2002 to that in 2005?
Offer a very short reply. 0.79. What is the ratio of the Expenses (in $) in Italy in 2002 to that in 2005?
Give a very brief answer. 1.1. What is the ratio of the Expenses (in $) in Namibia in 2002 to that in 2005?
Provide a short and direct response. 1.11. What is the ratio of the Expenses (in $) of St. Kitts and Nevis in 2002 to that in 2005?
Ensure brevity in your answer.  0.95. What is the ratio of the Expenses (in $) of Belgium in 2002 to that in 2006?
Keep it short and to the point. 0.85. What is the ratio of the Expenses (in $) in Italy in 2002 to that in 2006?
Ensure brevity in your answer.  0.94. What is the ratio of the Expenses (in $) of Namibia in 2002 to that in 2006?
Your answer should be compact. 0.69. What is the ratio of the Expenses (in $) in St. Kitts and Nevis in 2002 to that in 2006?
Your answer should be compact. 0.8. What is the ratio of the Expenses (in $) in Belgium in 2003 to that in 2004?
Your answer should be very brief. 2.92. What is the ratio of the Expenses (in $) in Italy in 2003 to that in 2004?
Offer a very short reply. 0.96. What is the ratio of the Expenses (in $) of Namibia in 2003 to that in 2004?
Your answer should be compact. 1.15. What is the ratio of the Expenses (in $) of St. Kitts and Nevis in 2003 to that in 2004?
Make the answer very short. 1.07. What is the ratio of the Expenses (in $) in Belgium in 2003 to that in 2005?
Your response must be concise. 2.04. What is the ratio of the Expenses (in $) of Italy in 2003 to that in 2005?
Make the answer very short. 1.03. What is the ratio of the Expenses (in $) in Namibia in 2003 to that in 2005?
Your answer should be very brief. 0.94. What is the ratio of the Expenses (in $) in St. Kitts and Nevis in 2003 to that in 2005?
Offer a terse response. 0.77. What is the ratio of the Expenses (in $) of Belgium in 2003 to that in 2006?
Your answer should be very brief. 2.19. What is the ratio of the Expenses (in $) in Italy in 2003 to that in 2006?
Provide a short and direct response. 0.88. What is the ratio of the Expenses (in $) of Namibia in 2003 to that in 2006?
Keep it short and to the point. 0.59. What is the ratio of the Expenses (in $) in St. Kitts and Nevis in 2003 to that in 2006?
Your answer should be compact. 0.65. What is the ratio of the Expenses (in $) in Belgium in 2004 to that in 2005?
Keep it short and to the point. 0.7. What is the ratio of the Expenses (in $) of Italy in 2004 to that in 2005?
Give a very brief answer. 1.08. What is the ratio of the Expenses (in $) in Namibia in 2004 to that in 2005?
Provide a succinct answer. 0.82. What is the ratio of the Expenses (in $) in St. Kitts and Nevis in 2004 to that in 2005?
Your answer should be very brief. 0.72. What is the ratio of the Expenses (in $) of Belgium in 2004 to that in 2006?
Provide a short and direct response. 0.75. What is the ratio of the Expenses (in $) of Italy in 2004 to that in 2006?
Your answer should be very brief. 0.92. What is the ratio of the Expenses (in $) of Namibia in 2004 to that in 2006?
Provide a succinct answer. 0.51. What is the ratio of the Expenses (in $) of St. Kitts and Nevis in 2004 to that in 2006?
Offer a very short reply. 0.61. What is the ratio of the Expenses (in $) in Belgium in 2005 to that in 2006?
Provide a short and direct response. 1.07. What is the ratio of the Expenses (in $) in Italy in 2005 to that in 2006?
Provide a short and direct response. 0.85. What is the ratio of the Expenses (in $) of Namibia in 2005 to that in 2006?
Your response must be concise. 0.63. What is the ratio of the Expenses (in $) of St. Kitts and Nevis in 2005 to that in 2006?
Give a very brief answer. 0.84. What is the difference between the highest and the second highest Expenses (in $) in Belgium?
Give a very brief answer. 4.20e+09. What is the difference between the highest and the second highest Expenses (in $) of Italy?
Your answer should be very brief. 1.26e+09. What is the difference between the highest and the second highest Expenses (in $) in Namibia?
Keep it short and to the point. 5.33e+08. What is the difference between the highest and the second highest Expenses (in $) in St. Kitts and Nevis?
Your response must be concise. 2.26e+07. What is the difference between the highest and the lowest Expenses (in $) in Belgium?
Offer a terse response. 5.41e+09. What is the difference between the highest and the lowest Expenses (in $) of Italy?
Provide a short and direct response. 3.68e+09. What is the difference between the highest and the lowest Expenses (in $) in Namibia?
Your response must be concise. 8.90e+08. What is the difference between the highest and the lowest Expenses (in $) of St. Kitts and Nevis?
Your answer should be very brief. 5.68e+07. 